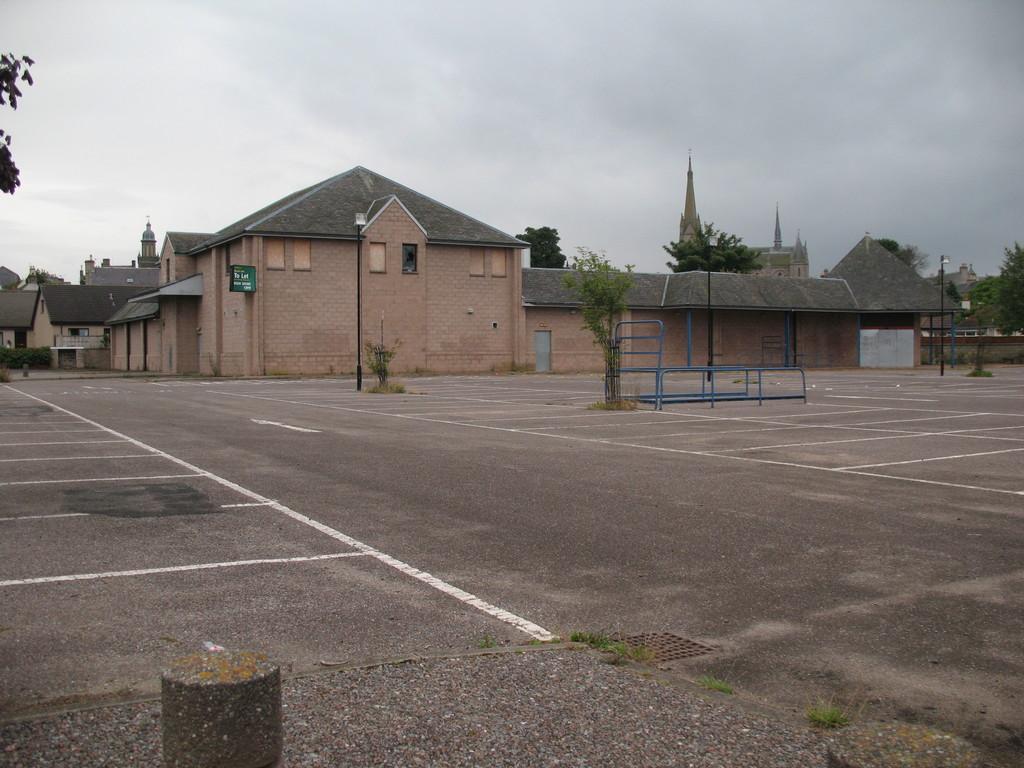In one or two sentences, can you explain what this image depicts? In this picture we can see road, plants, poles, rods and grass. In the background of the image we can see buildings, trees, board and sky. 